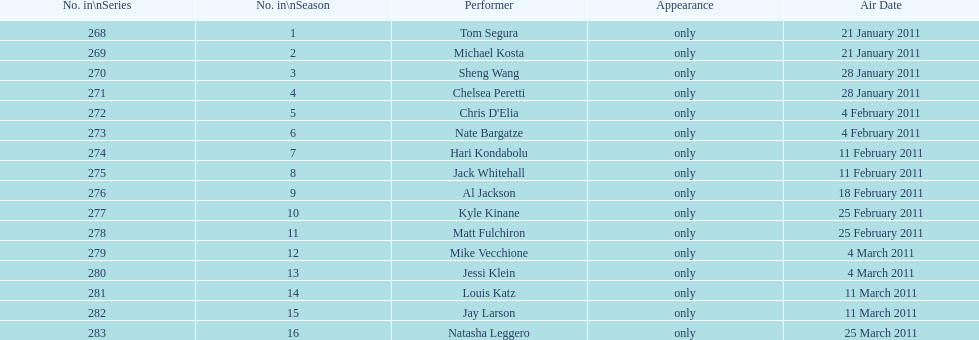Did al jackson broadcast before or after kyle kinane? Before. 